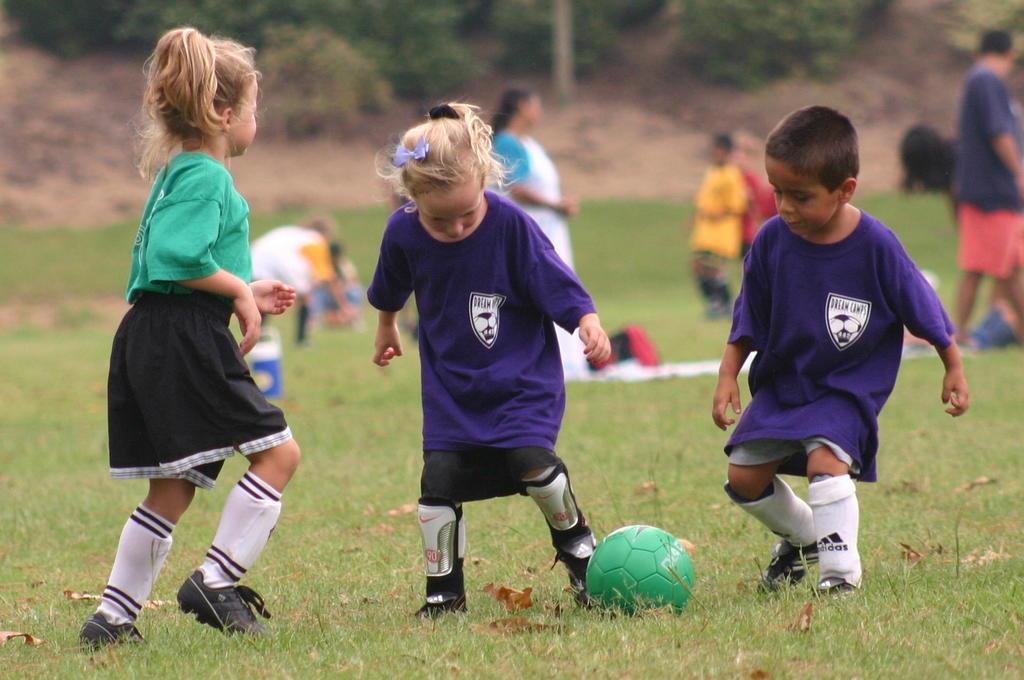What are the kids doing in the image? The kids are playing with a ball in the image. Where are the kids playing? The kids are playing on a ground. Who else is present in the image besides the kids? There is a woman and a man standing in the image. Can you describe the background of the image? The background of the image is blurred. What type of jeans is the cloth made of in the image? There is no mention of jeans or cloth in the image; it features kids playing with a ball, a woman, and a man standing nearby. 